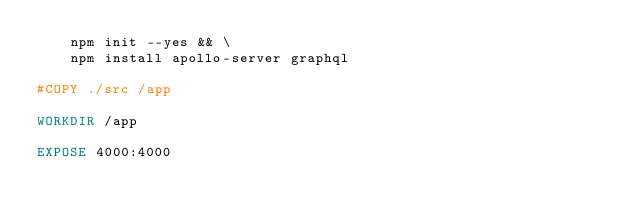<code> <loc_0><loc_0><loc_500><loc_500><_Dockerfile_>    npm init --yes && \
    npm install apollo-server graphql 

#COPY ./src /app

WORKDIR /app

EXPOSE 4000:4000
</code> 